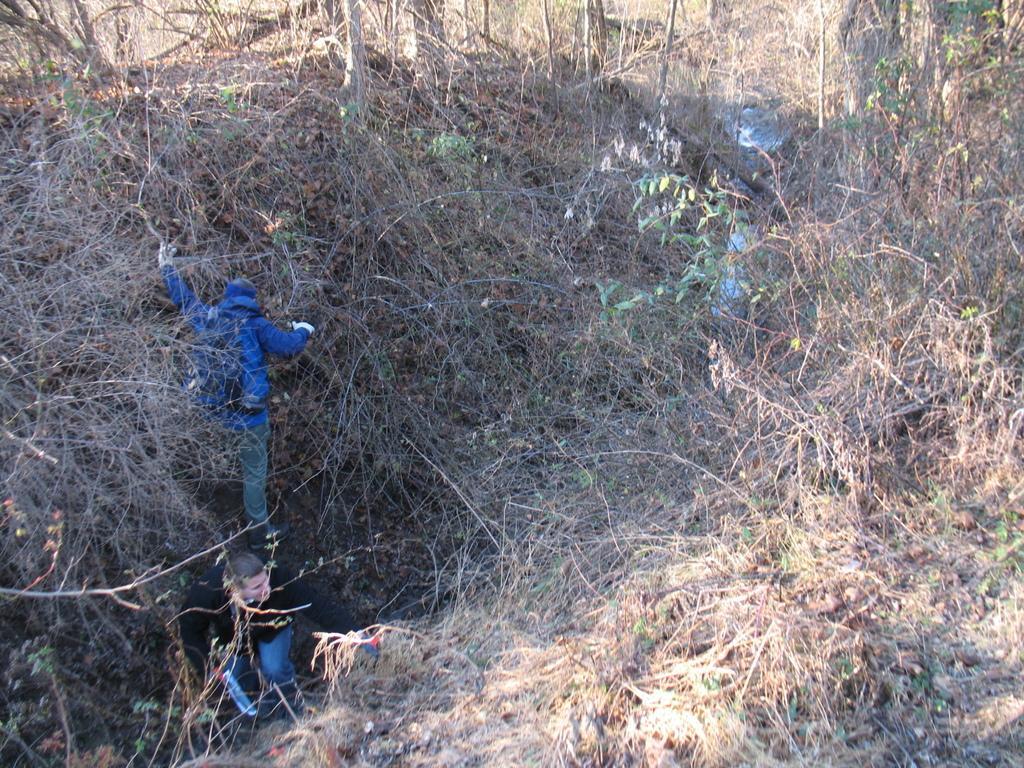Can you describe this image briefly? In this picture I can observe two members on the left side. There are some dried plants and trees in this picture. One of the men is wearing blue color hoodie. 